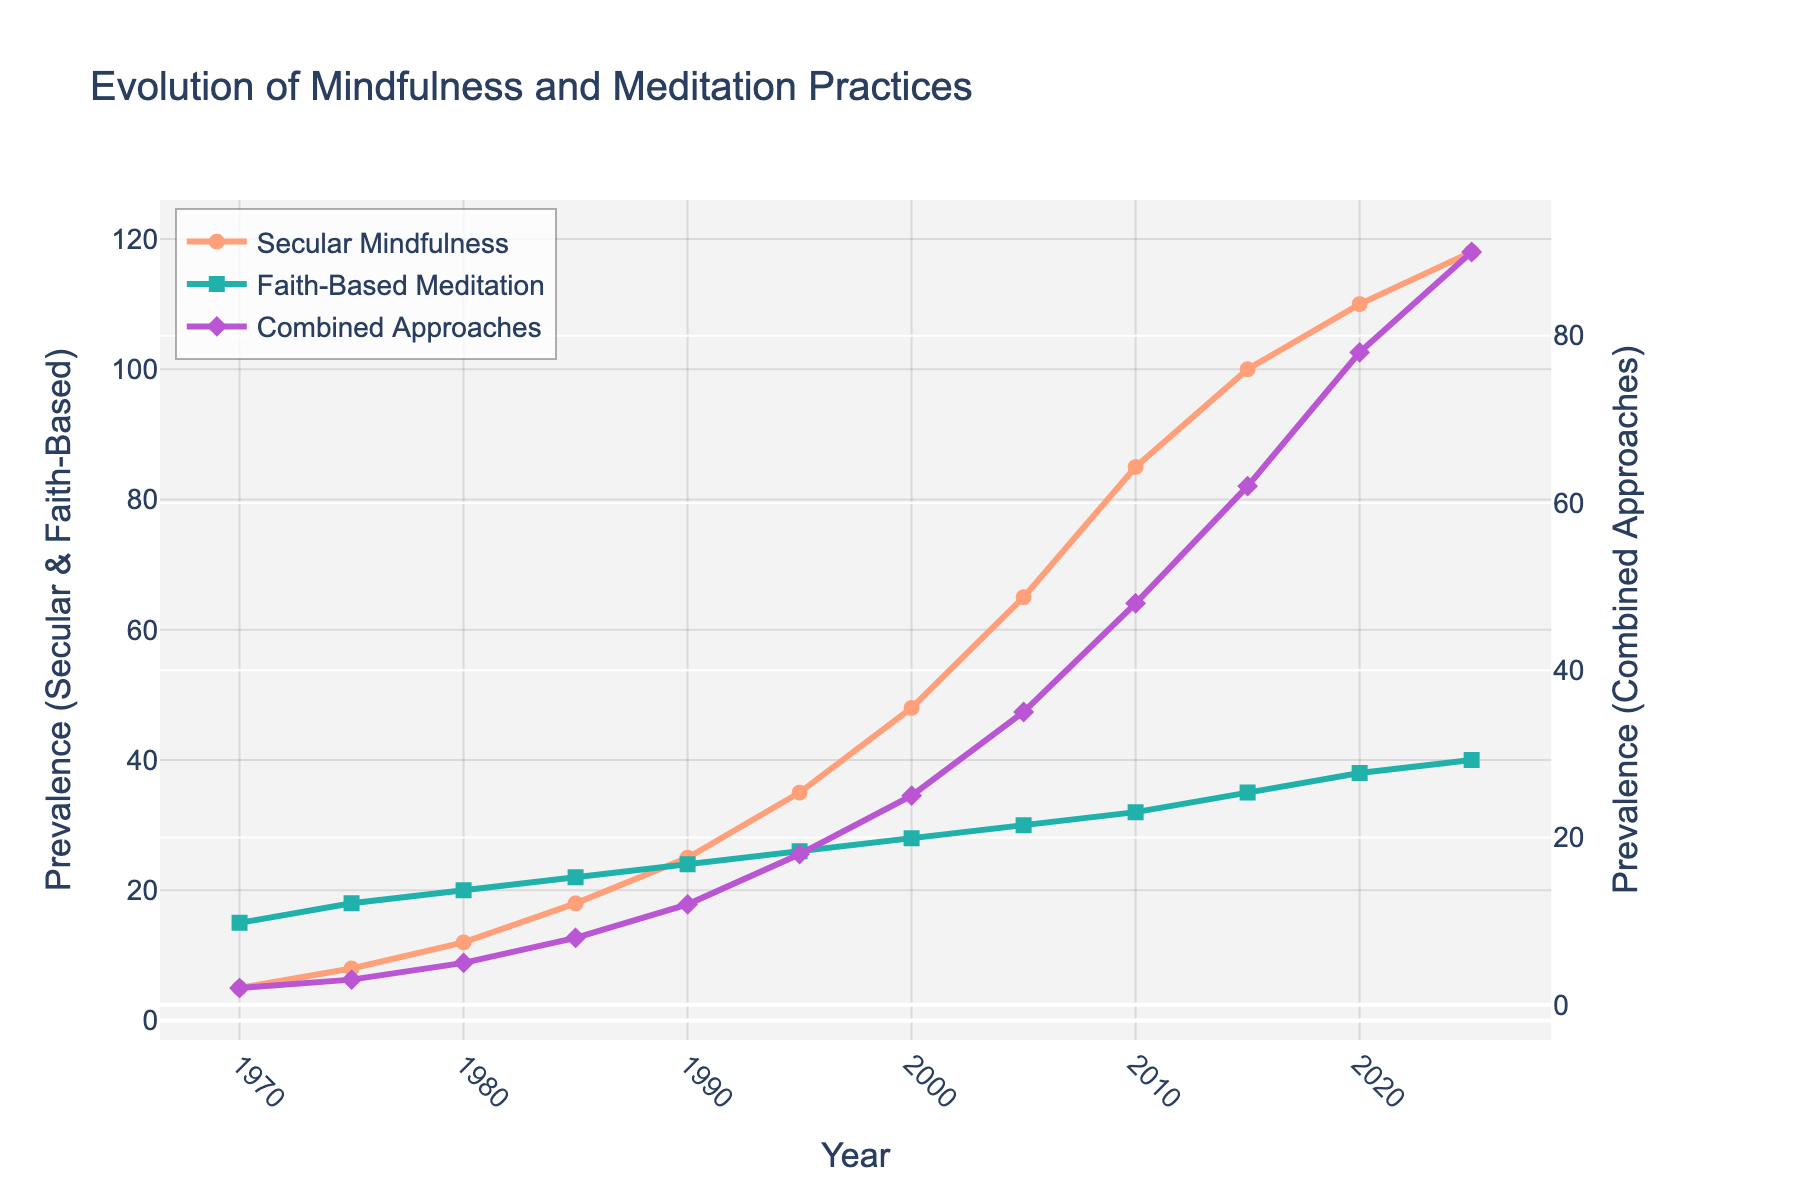What is the trend of faith-based meditation practices from 1970 to 2025? To identify the trend, look at the green line representing faith-based meditation practices in the chart. It starts at 15 in 1970 and gradually increases to 40 by 2025, showing a consistent upward trend.
Answer: Upward trend In which year did secular mindfulness practices surpass 50? By examining the orange line representing secular mindfulness, it surpasses the value of 50 between 1995 and 2000. Checking the data point for 2000, it reaches 48, which is still below 50, but in 2005 it rises to 65. Thus, secular mindfulness surpasses 50 in 2005.
Answer: 2005 Compare the prevalence of secular mindfulness and combined approaches in 2020. Which has a higher value? Look at the year 2020 on the x-axis and then compare the values of the orange and purple lines. Secular Mindfulness has a value of 110, and Combined Approaches have a value of 78. Thus, Secular Mindfulness has a higher value in 2020.
Answer: Secular Mindfulness How much did the combined approaches increase from 1970 to 2025? Look at the purple line at the start point (1970) and end point (2025). In 1970, the value is 2, and in 2025, it is 90. Calculate the increase by subtracting the initial value from the final value: 90 - 2 = 88.
Answer: 88 By how much did faith-based meditation practices increase between 1990 and 2015? Locate the Faith-Based Meditation line's values for 1990 and 2015. In 1990, the value is 24, and in 2015, it is 35. Subtract the 1990 value from the 2015 value: 35 - 24 = 11.
Answer: 11 What is the difference between secular mindfulness and faith-based meditation practices in 2025? Check the values for 2025 for both secular mindfulness and faith-based meditation. Secular Mindfulness has a value of 118, Faith-Based Meditation has a value of 40. The difference is 118 - 40 = 78.
Answer: 78 When did combined approaches reach a prevalence value of 50? Locate the purple line to find the point where the combined approaches' value is 50. It crosses the 50-mark between 2010 and 2015. Checking the data, it happens exactly in 2015 when it reaches 62.
Answer: 2015 What is the average increase per decade for secular mindfulness from 1970 to 2020? To find this, calculate the total increase from 1970 to 2020, which is 110 - 5 = 105. Then, divide this by the number of decades (5): 105 / 5 = 21.
Answer: 21 